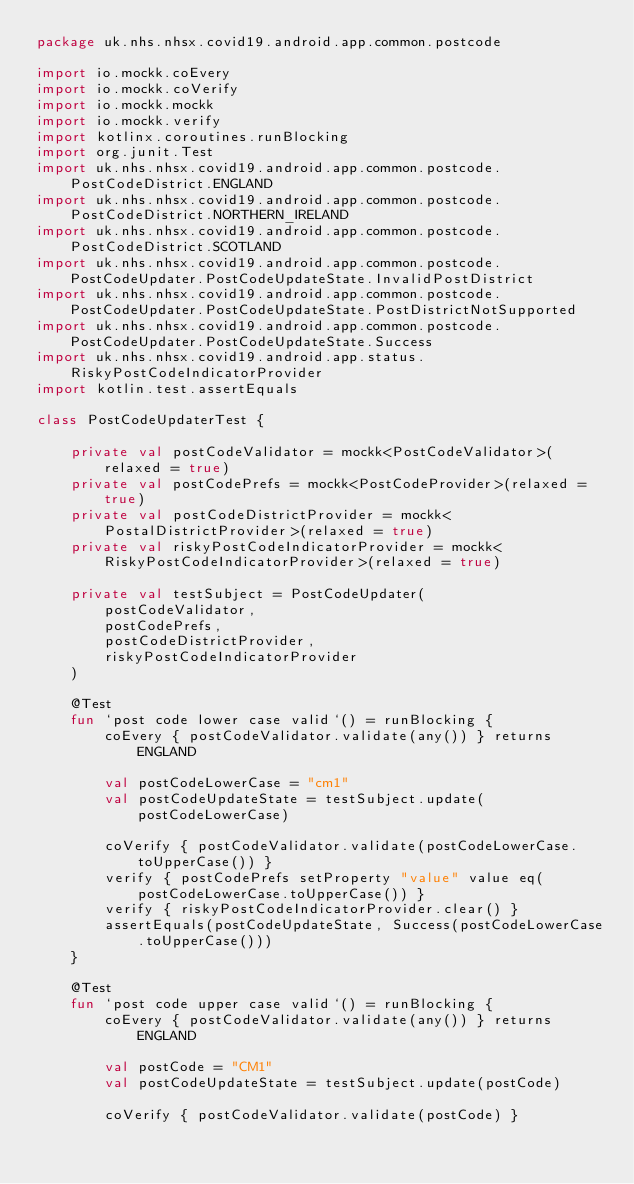<code> <loc_0><loc_0><loc_500><loc_500><_Kotlin_>package uk.nhs.nhsx.covid19.android.app.common.postcode

import io.mockk.coEvery
import io.mockk.coVerify
import io.mockk.mockk
import io.mockk.verify
import kotlinx.coroutines.runBlocking
import org.junit.Test
import uk.nhs.nhsx.covid19.android.app.common.postcode.PostCodeDistrict.ENGLAND
import uk.nhs.nhsx.covid19.android.app.common.postcode.PostCodeDistrict.NORTHERN_IRELAND
import uk.nhs.nhsx.covid19.android.app.common.postcode.PostCodeDistrict.SCOTLAND
import uk.nhs.nhsx.covid19.android.app.common.postcode.PostCodeUpdater.PostCodeUpdateState.InvalidPostDistrict
import uk.nhs.nhsx.covid19.android.app.common.postcode.PostCodeUpdater.PostCodeUpdateState.PostDistrictNotSupported
import uk.nhs.nhsx.covid19.android.app.common.postcode.PostCodeUpdater.PostCodeUpdateState.Success
import uk.nhs.nhsx.covid19.android.app.status.RiskyPostCodeIndicatorProvider
import kotlin.test.assertEquals

class PostCodeUpdaterTest {

    private val postCodeValidator = mockk<PostCodeValidator>(relaxed = true)
    private val postCodePrefs = mockk<PostCodeProvider>(relaxed = true)
    private val postCodeDistrictProvider = mockk<PostalDistrictProvider>(relaxed = true)
    private val riskyPostCodeIndicatorProvider = mockk<RiskyPostCodeIndicatorProvider>(relaxed = true)

    private val testSubject = PostCodeUpdater(
        postCodeValidator,
        postCodePrefs,
        postCodeDistrictProvider,
        riskyPostCodeIndicatorProvider
    )

    @Test
    fun `post code lower case valid`() = runBlocking {
        coEvery { postCodeValidator.validate(any()) } returns ENGLAND

        val postCodeLowerCase = "cm1"
        val postCodeUpdateState = testSubject.update(postCodeLowerCase)

        coVerify { postCodeValidator.validate(postCodeLowerCase.toUpperCase()) }
        verify { postCodePrefs setProperty "value" value eq(postCodeLowerCase.toUpperCase()) }
        verify { riskyPostCodeIndicatorProvider.clear() }
        assertEquals(postCodeUpdateState, Success(postCodeLowerCase.toUpperCase()))
    }

    @Test
    fun `post code upper case valid`() = runBlocking {
        coEvery { postCodeValidator.validate(any()) } returns ENGLAND

        val postCode = "CM1"
        val postCodeUpdateState = testSubject.update(postCode)

        coVerify { postCodeValidator.validate(postCode) }</code> 